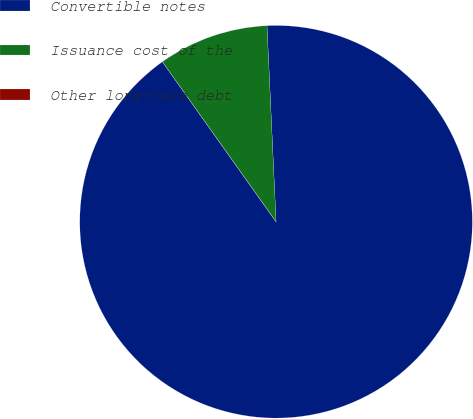Convert chart to OTSL. <chart><loc_0><loc_0><loc_500><loc_500><pie_chart><fcel>Convertible notes<fcel>Issuance cost of the<fcel>Other long-term debt<nl><fcel>90.9%<fcel>9.09%<fcel>0.0%<nl></chart> 